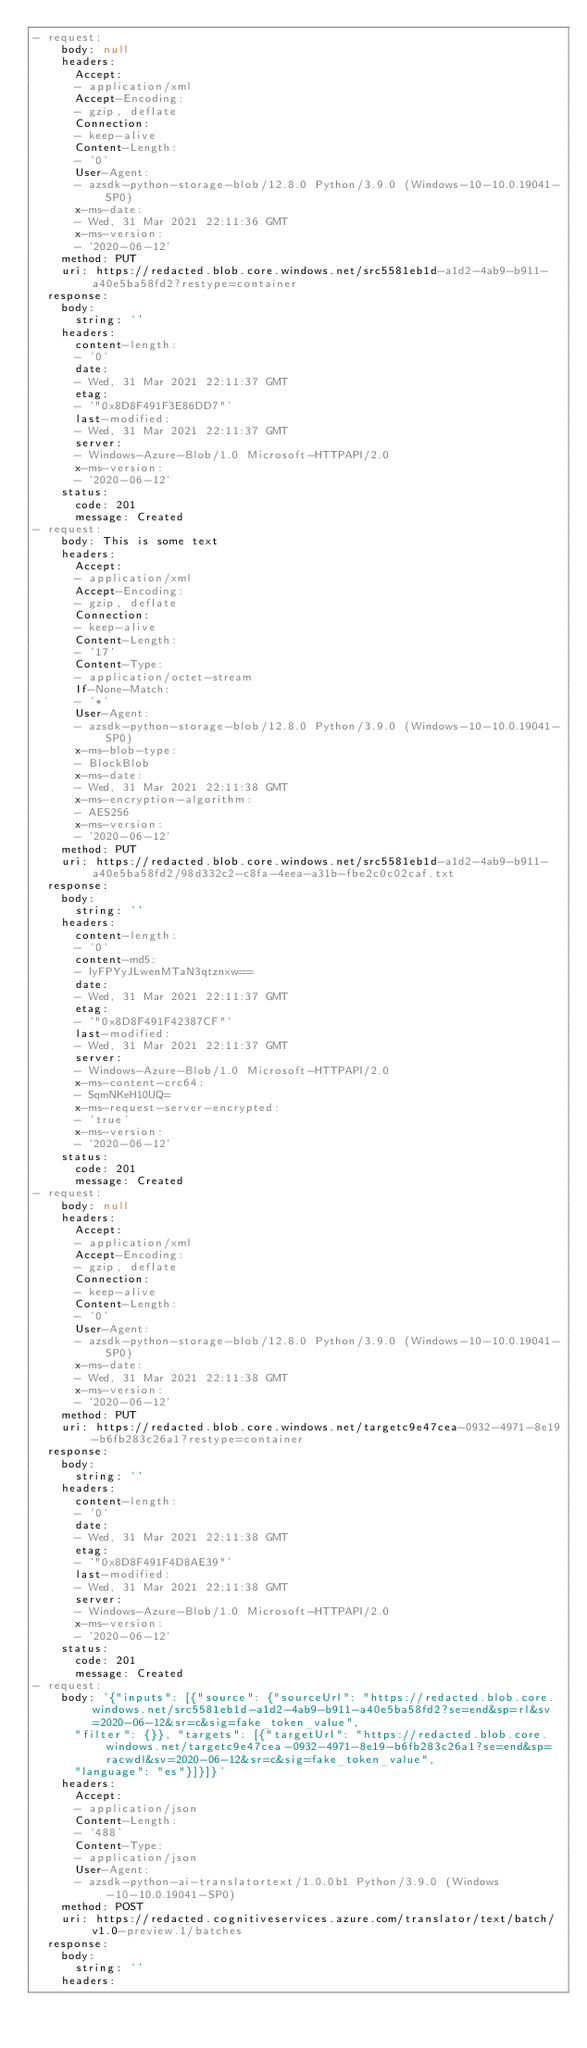Convert code to text. <code><loc_0><loc_0><loc_500><loc_500><_YAML_>- request:
    body: null
    headers:
      Accept:
      - application/xml
      Accept-Encoding:
      - gzip, deflate
      Connection:
      - keep-alive
      Content-Length:
      - '0'
      User-Agent:
      - azsdk-python-storage-blob/12.8.0 Python/3.9.0 (Windows-10-10.0.19041-SP0)
      x-ms-date:
      - Wed, 31 Mar 2021 22:11:36 GMT
      x-ms-version:
      - '2020-06-12'
    method: PUT
    uri: https://redacted.blob.core.windows.net/src5581eb1d-a1d2-4ab9-b911-a40e5ba58fd2?restype=container
  response:
    body:
      string: ''
    headers:
      content-length:
      - '0'
      date:
      - Wed, 31 Mar 2021 22:11:37 GMT
      etag:
      - '"0x8D8F491F3E86DD7"'
      last-modified:
      - Wed, 31 Mar 2021 22:11:37 GMT
      server:
      - Windows-Azure-Blob/1.0 Microsoft-HTTPAPI/2.0
      x-ms-version:
      - '2020-06-12'
    status:
      code: 201
      message: Created
- request:
    body: This is some text
    headers:
      Accept:
      - application/xml
      Accept-Encoding:
      - gzip, deflate
      Connection:
      - keep-alive
      Content-Length:
      - '17'
      Content-Type:
      - application/octet-stream
      If-None-Match:
      - '*'
      User-Agent:
      - azsdk-python-storage-blob/12.8.0 Python/3.9.0 (Windows-10-10.0.19041-SP0)
      x-ms-blob-type:
      - BlockBlob
      x-ms-date:
      - Wed, 31 Mar 2021 22:11:38 GMT
      x-ms-encryption-algorithm:
      - AES256
      x-ms-version:
      - '2020-06-12'
    method: PUT
    uri: https://redacted.blob.core.windows.net/src5581eb1d-a1d2-4ab9-b911-a40e5ba58fd2/98d332c2-c8fa-4eea-a31b-fbe2c0c02caf.txt
  response:
    body:
      string: ''
    headers:
      content-length:
      - '0'
      content-md5:
      - lyFPYyJLwenMTaN3qtznxw==
      date:
      - Wed, 31 Mar 2021 22:11:37 GMT
      etag:
      - '"0x8D8F491F42387CF"'
      last-modified:
      - Wed, 31 Mar 2021 22:11:37 GMT
      server:
      - Windows-Azure-Blob/1.0 Microsoft-HTTPAPI/2.0
      x-ms-content-crc64:
      - SqmNKeH10UQ=
      x-ms-request-server-encrypted:
      - 'true'
      x-ms-version:
      - '2020-06-12'
    status:
      code: 201
      message: Created
- request:
    body: null
    headers:
      Accept:
      - application/xml
      Accept-Encoding:
      - gzip, deflate
      Connection:
      - keep-alive
      Content-Length:
      - '0'
      User-Agent:
      - azsdk-python-storage-blob/12.8.0 Python/3.9.0 (Windows-10-10.0.19041-SP0)
      x-ms-date:
      - Wed, 31 Mar 2021 22:11:38 GMT
      x-ms-version:
      - '2020-06-12'
    method: PUT
    uri: https://redacted.blob.core.windows.net/targetc9e47cea-0932-4971-8e19-b6fb283c26a1?restype=container
  response:
    body:
      string: ''
    headers:
      content-length:
      - '0'
      date:
      - Wed, 31 Mar 2021 22:11:38 GMT
      etag:
      - '"0x8D8F491F4D8AE39"'
      last-modified:
      - Wed, 31 Mar 2021 22:11:38 GMT
      server:
      - Windows-Azure-Blob/1.0 Microsoft-HTTPAPI/2.0
      x-ms-version:
      - '2020-06-12'
    status:
      code: 201
      message: Created
- request:
    body: '{"inputs": [{"source": {"sourceUrl": "https://redacted.blob.core.windows.net/src5581eb1d-a1d2-4ab9-b911-a40e5ba58fd2?se=end&sp=rl&sv=2020-06-12&sr=c&sig=fake_token_value",
      "filter": {}}, "targets": [{"targetUrl": "https://redacted.blob.core.windows.net/targetc9e47cea-0932-4971-8e19-b6fb283c26a1?se=end&sp=racwdl&sv=2020-06-12&sr=c&sig=fake_token_value",
      "language": "es"}]}]}'
    headers:
      Accept:
      - application/json
      Content-Length:
      - '488'
      Content-Type:
      - application/json
      User-Agent:
      - azsdk-python-ai-translatortext/1.0.0b1 Python/3.9.0 (Windows-10-10.0.19041-SP0)
    method: POST
    uri: https://redacted.cognitiveservices.azure.com/translator/text/batch/v1.0-preview.1/batches
  response:
    body:
      string: ''
    headers:</code> 